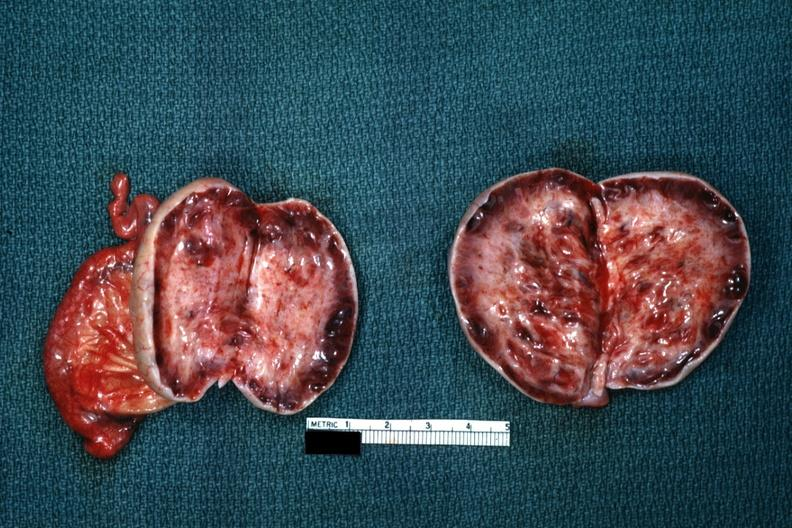s female reproductive present?
Answer the question using a single word or phrase. Yes 